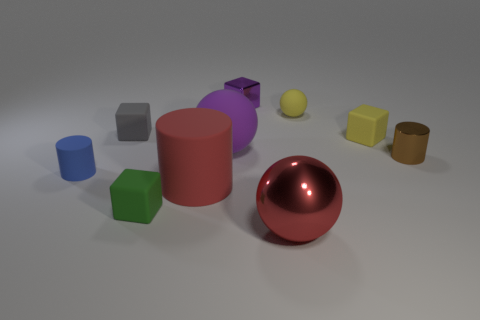What number of other things are there of the same shape as the large purple rubber thing?
Keep it short and to the point. 2. What color is the small shiny object that is behind the brown object?
Your response must be concise. Purple. Are the small gray object and the tiny purple cube made of the same material?
Make the answer very short. No. How many things are either tiny green matte cylinders or small matte things that are to the left of the small purple shiny cube?
Your response must be concise. 3. There is a rubber thing that is the same color as the tiny metallic block; what is its size?
Provide a succinct answer. Large. What shape is the large red object that is on the left side of the purple sphere?
Give a very brief answer. Cylinder. There is a tiny cylinder to the left of the large red ball; is it the same color as the large shiny sphere?
Your answer should be very brief. No. There is a object that is the same color as the big rubber cylinder; what material is it?
Offer a very short reply. Metal. Does the rubber sphere that is to the right of the purple cube have the same size as the purple metallic block?
Offer a terse response. Yes. Are there any other shiny spheres of the same color as the small sphere?
Make the answer very short. No. 